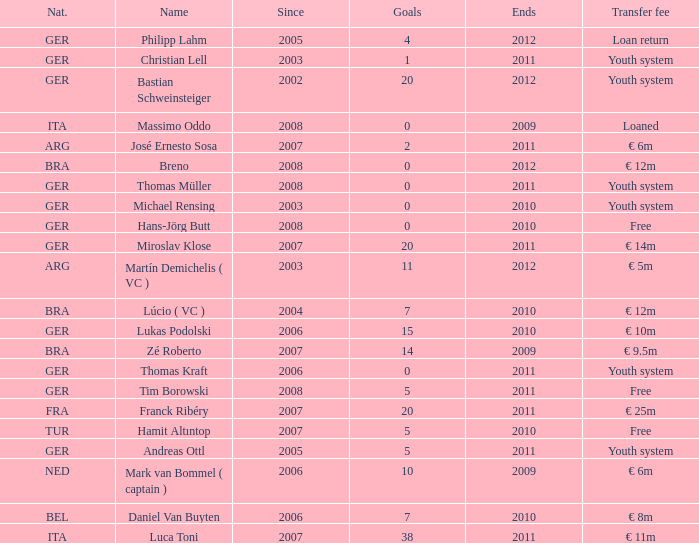What is the total number of ends after 2006 with a nationality of ita and 0 goals? 0.0. 